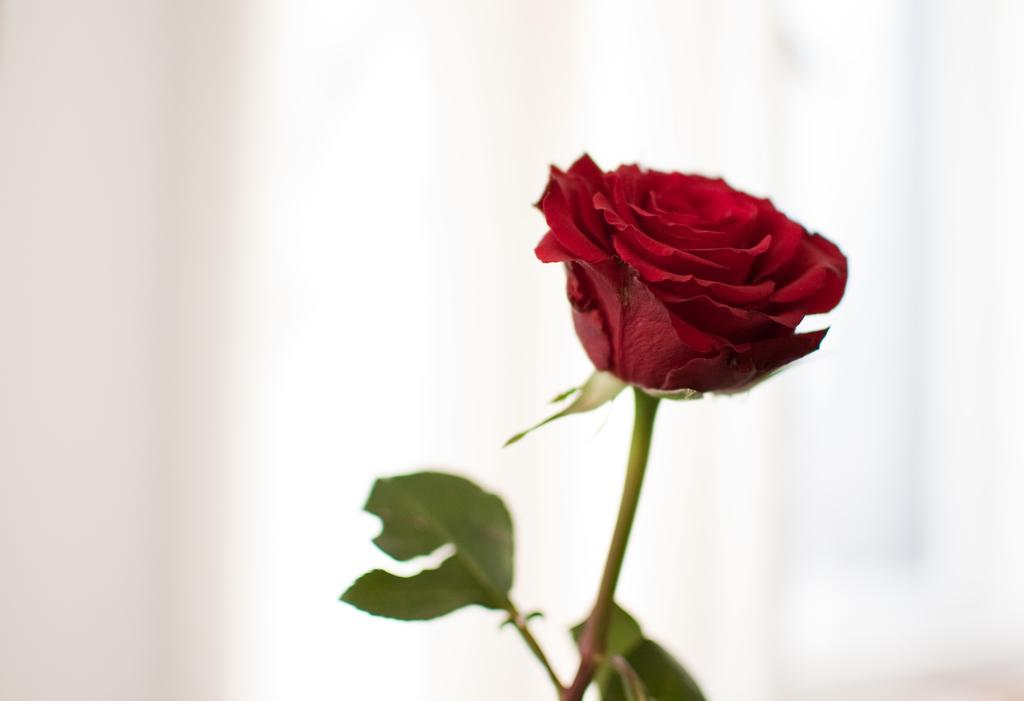What type of flower is in the image? There is a red color rose flower in the image. What parts of the rose flower can be seen in the image? The rose flower has a stem and leaves. What color is the background of the image? The background of the image is white. What type of milk is being poured over the rose flower in the image? There is no milk being poured over the rose flower in the image; it is a still image of a rose flower with a white background. 